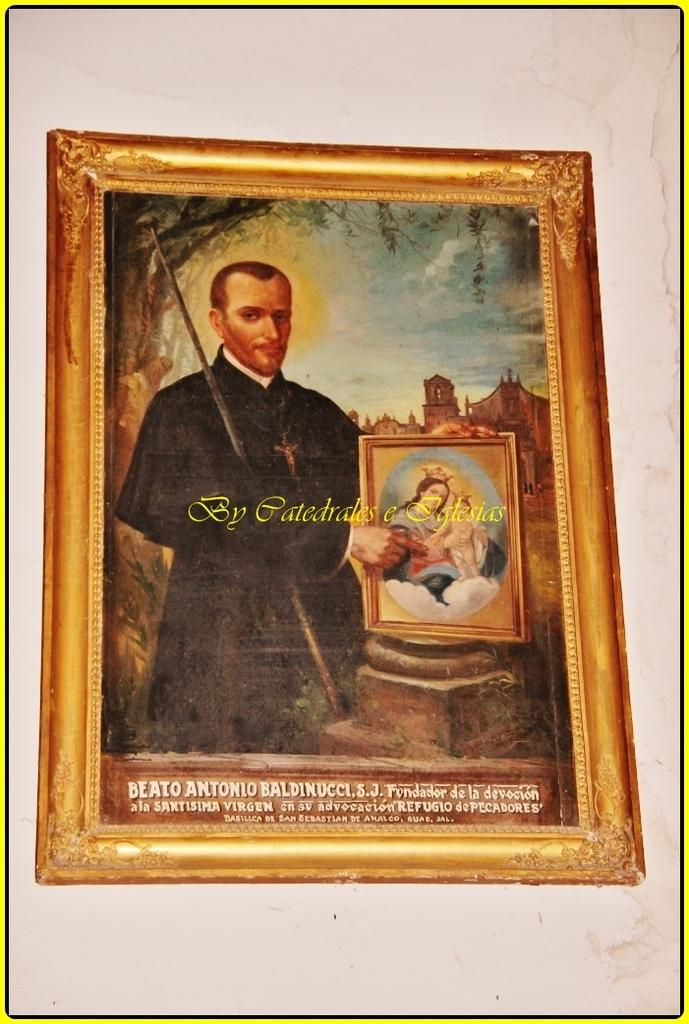Provide a one-sentence caption for the provided image. A painting of a man holding a panting by Catedrales e Iglesias. 